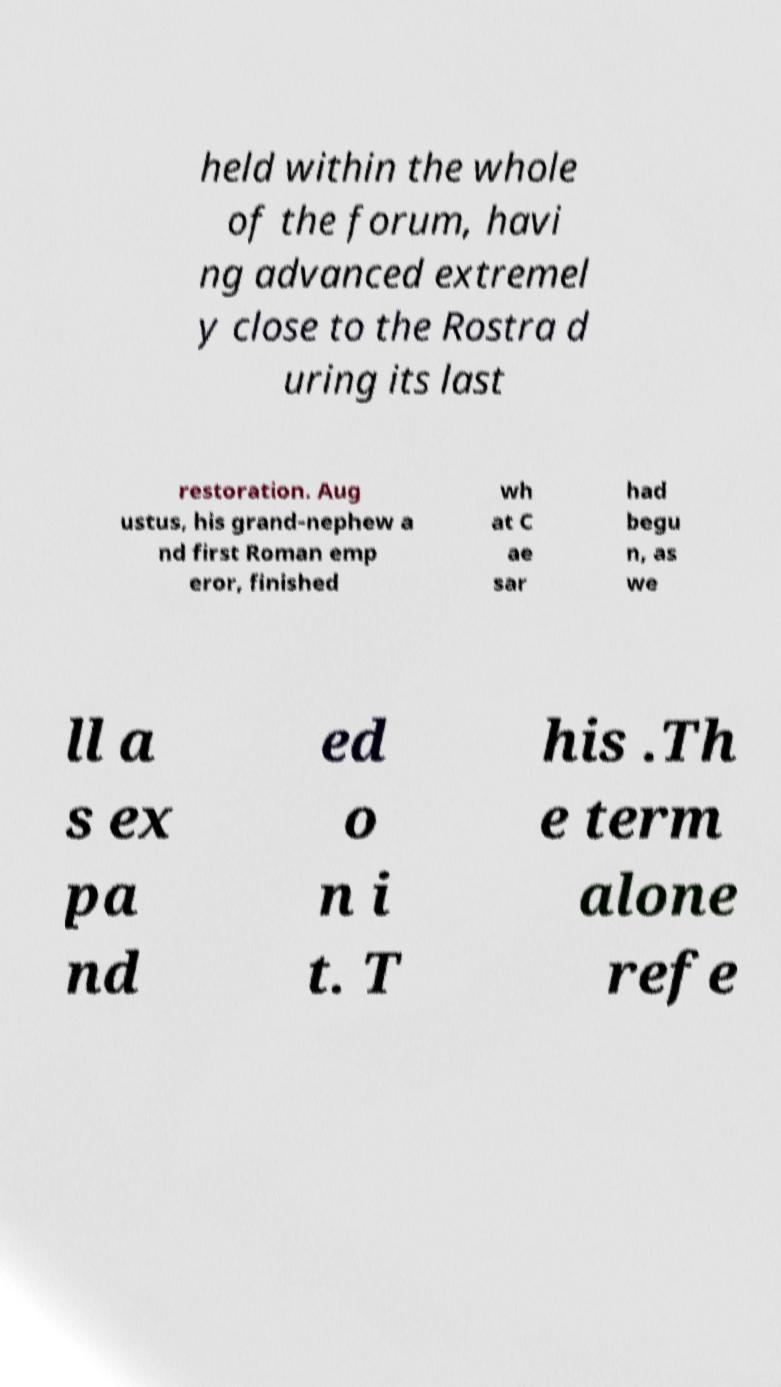Could you assist in decoding the text presented in this image and type it out clearly? held within the whole of the forum, havi ng advanced extremel y close to the Rostra d uring its last restoration. Aug ustus, his grand-nephew a nd first Roman emp eror, finished wh at C ae sar had begu n, as we ll a s ex pa nd ed o n i t. T his .Th e term alone refe 